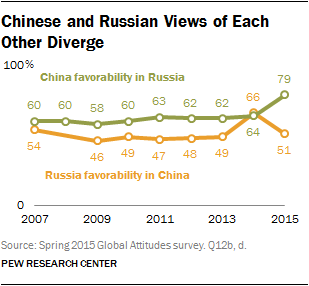List a handful of essential elements in this visual. The rightmost value of the orange graph is 51. 